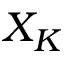<formula> <loc_0><loc_0><loc_500><loc_500>X _ { K }</formula> 